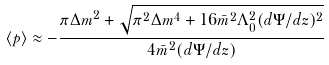<formula> <loc_0><loc_0><loc_500><loc_500>\langle p \rangle \approx - \frac { \pi \Delta m ^ { 2 } + \sqrt { \pi ^ { 2 } \Delta m ^ { 4 } + 1 6 \bar { m } ^ { 2 } \Lambda _ { 0 } ^ { 2 } ( d \Psi / d z ) ^ { 2 } } } { 4 \bar { m } ^ { 2 } ( d \Psi / d z ) }</formula> 